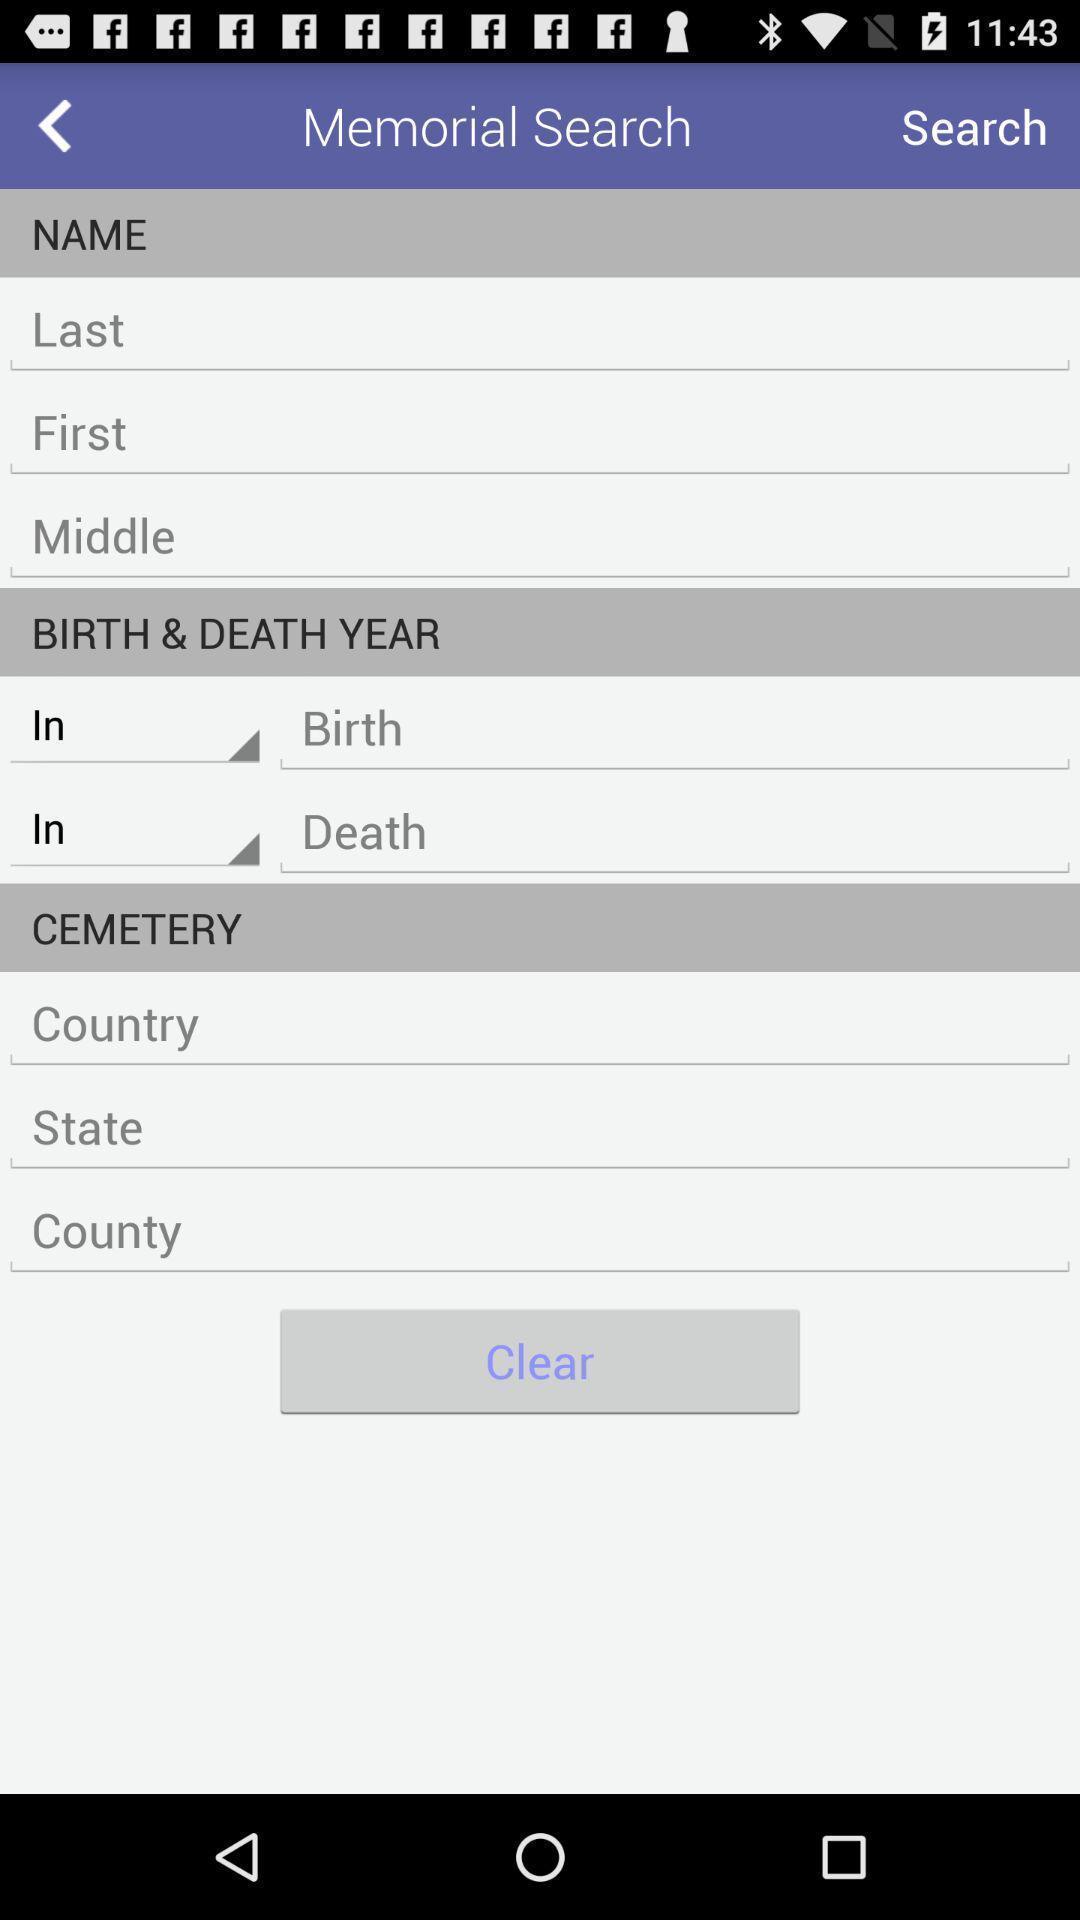Describe the key features of this screenshot. Search page of a memorial finder app. 